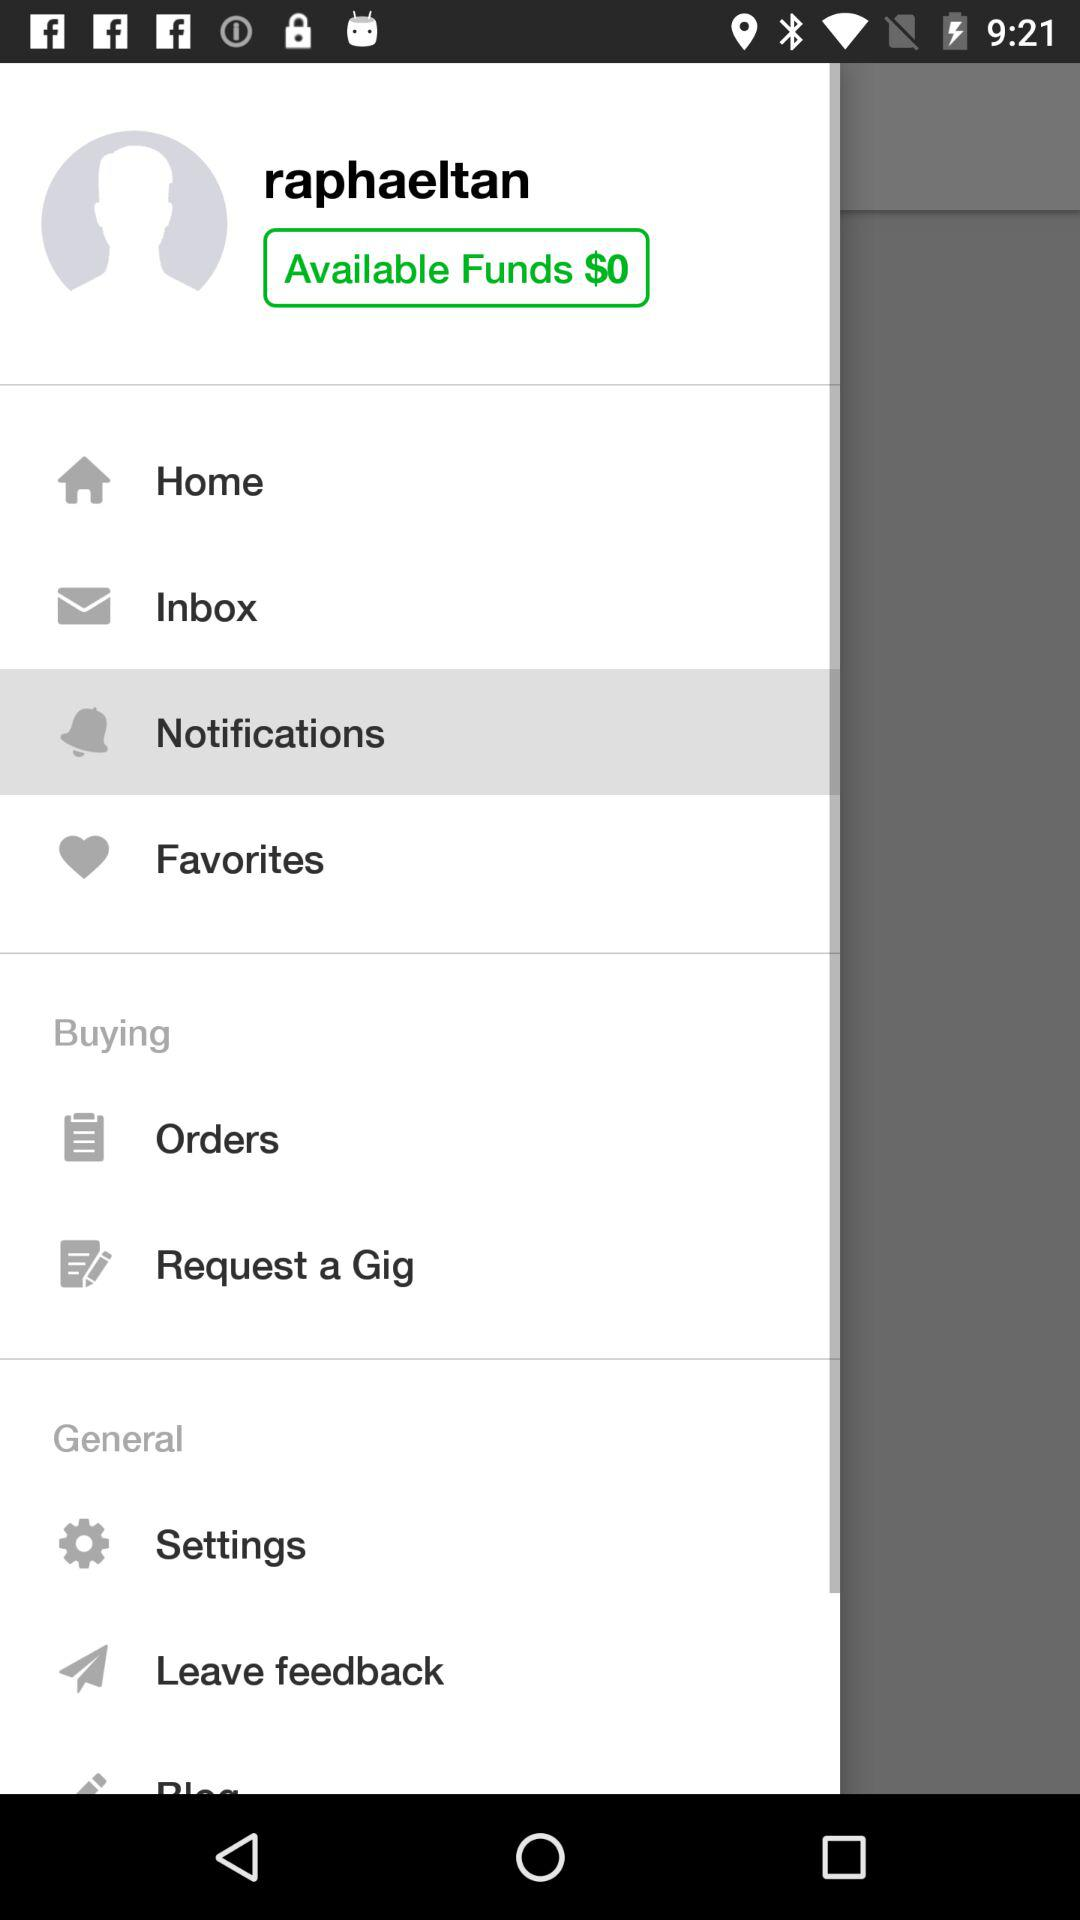What's the user profile name? The profile name is "raphaeltan". 